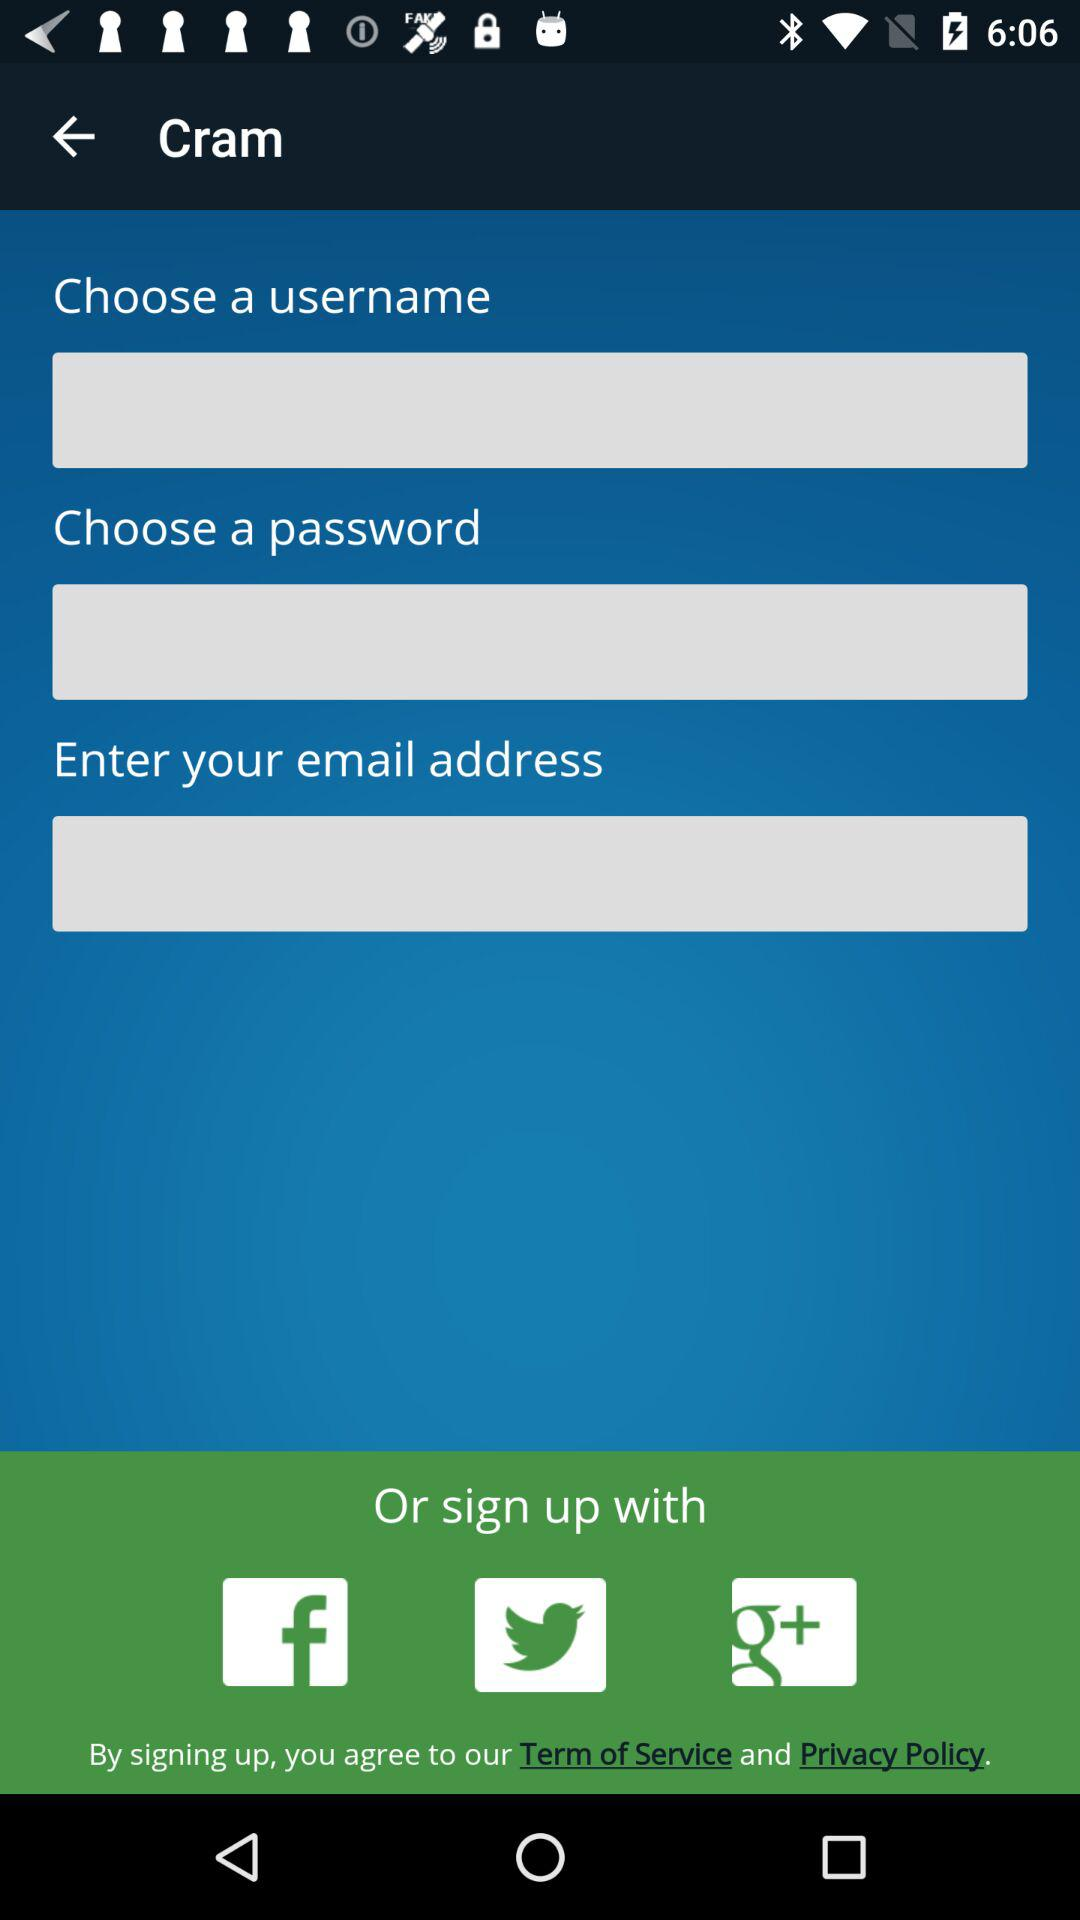What is the application name?
When the provided information is insufficient, respond with <no answer>. <no answer> 